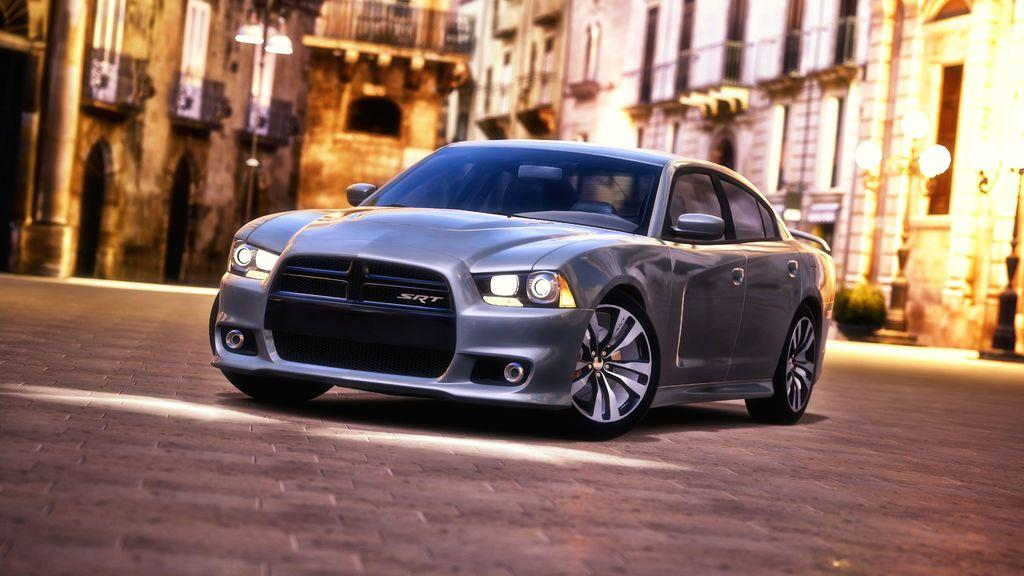What type of structures can be seen in the image? There are buildings visible in the image. Where are the buildings located in the image? The buildings are at the top of the image. What is located in the middle of the image? There is a car in the middle of the image. Can you see any crackers in the image? There are no crackers present in the image. Is there a frog visible in the image? There is no frog visible in the image. 